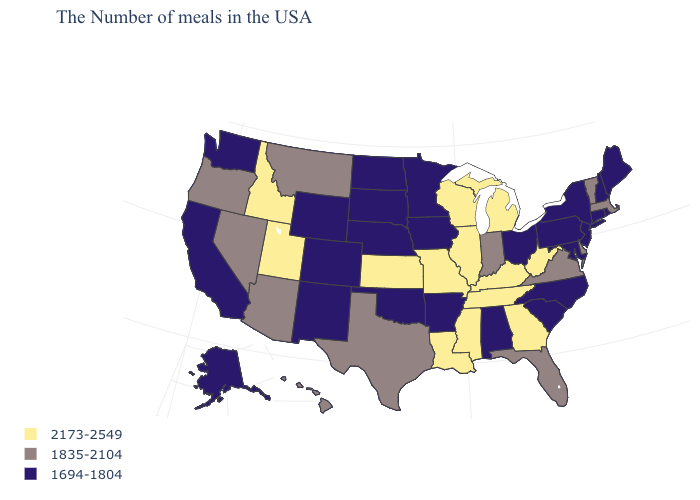What is the value of Vermont?
Give a very brief answer. 1835-2104. Does the map have missing data?
Concise answer only. No. What is the value of Wisconsin?
Short answer required. 2173-2549. What is the value of Indiana?
Answer briefly. 1835-2104. Does Arizona have the highest value in the West?
Concise answer only. No. What is the value of Vermont?
Be succinct. 1835-2104. Name the states that have a value in the range 1694-1804?
Short answer required. Maine, Rhode Island, New Hampshire, Connecticut, New York, New Jersey, Maryland, Pennsylvania, North Carolina, South Carolina, Ohio, Alabama, Arkansas, Minnesota, Iowa, Nebraska, Oklahoma, South Dakota, North Dakota, Wyoming, Colorado, New Mexico, California, Washington, Alaska. Does Wisconsin have the highest value in the USA?
Concise answer only. Yes. Name the states that have a value in the range 1835-2104?
Write a very short answer. Massachusetts, Vermont, Delaware, Virginia, Florida, Indiana, Texas, Montana, Arizona, Nevada, Oregon, Hawaii. What is the highest value in states that border South Dakota?
Keep it brief. 1835-2104. Which states have the lowest value in the USA?
Write a very short answer. Maine, Rhode Island, New Hampshire, Connecticut, New York, New Jersey, Maryland, Pennsylvania, North Carolina, South Carolina, Ohio, Alabama, Arkansas, Minnesota, Iowa, Nebraska, Oklahoma, South Dakota, North Dakota, Wyoming, Colorado, New Mexico, California, Washington, Alaska. Which states have the highest value in the USA?
Quick response, please. West Virginia, Georgia, Michigan, Kentucky, Tennessee, Wisconsin, Illinois, Mississippi, Louisiana, Missouri, Kansas, Utah, Idaho. Name the states that have a value in the range 1835-2104?
Be succinct. Massachusetts, Vermont, Delaware, Virginia, Florida, Indiana, Texas, Montana, Arizona, Nevada, Oregon, Hawaii. Among the states that border Maryland , does Pennsylvania have the lowest value?
Quick response, please. Yes. What is the value of Virginia?
Give a very brief answer. 1835-2104. 